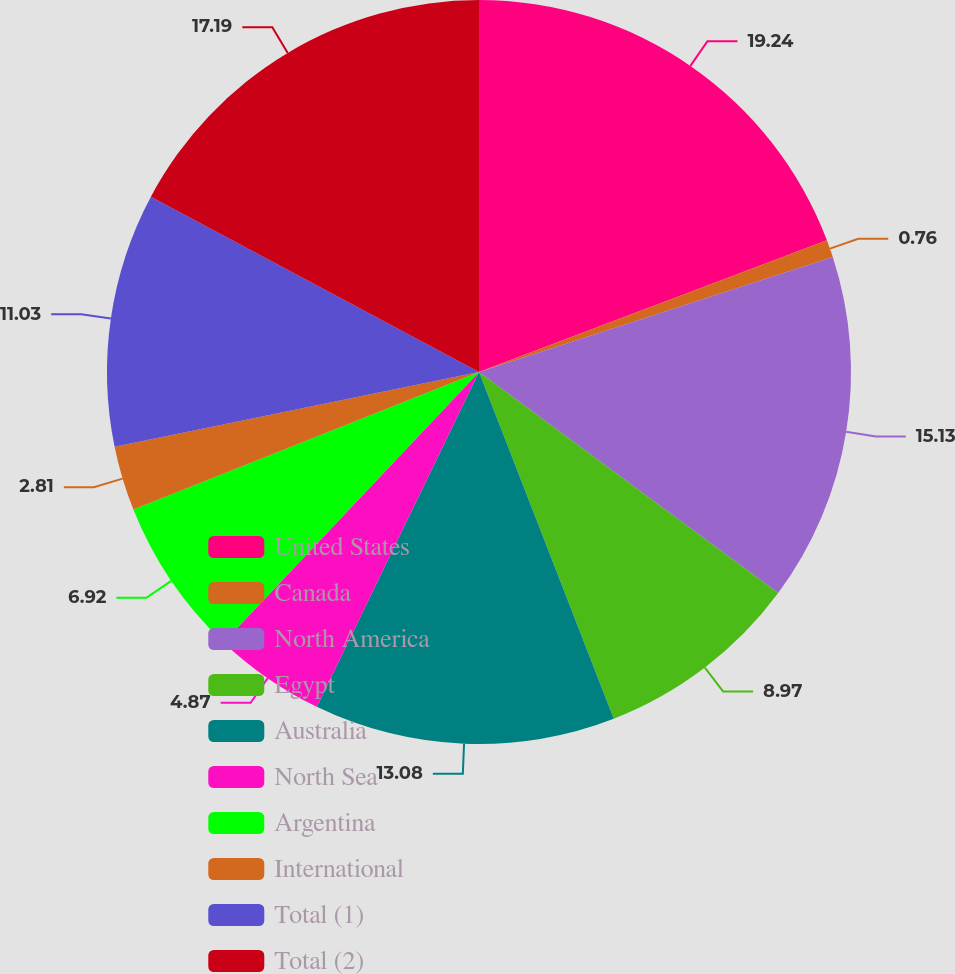<chart> <loc_0><loc_0><loc_500><loc_500><pie_chart><fcel>United States<fcel>Canada<fcel>North America<fcel>Egypt<fcel>Australia<fcel>North Sea<fcel>Argentina<fcel>International<fcel>Total (1)<fcel>Total (2)<nl><fcel>19.24%<fcel>0.76%<fcel>15.13%<fcel>8.97%<fcel>13.08%<fcel>4.87%<fcel>6.92%<fcel>2.81%<fcel>11.03%<fcel>17.19%<nl></chart> 